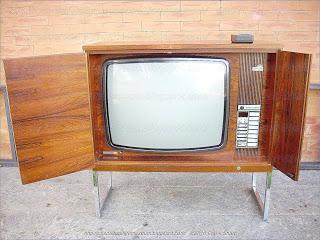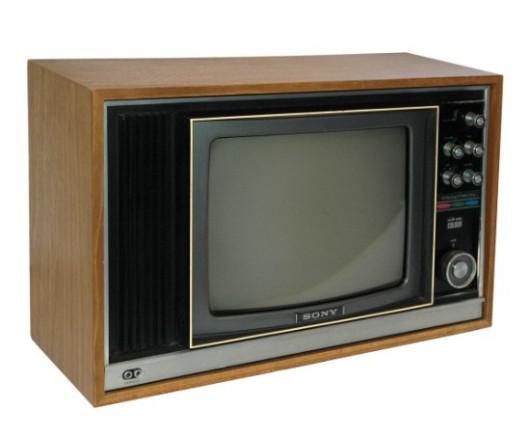The first image is the image on the left, the second image is the image on the right. Examine the images to the left and right. Is the description "An image shows an old-fashioned wood-cased TV set elevated off the ground on some type of legs." accurate? Answer yes or no. Yes. The first image is the image on the left, the second image is the image on the right. For the images displayed, is the sentence "One of the televisions is not the console type." factually correct? Answer yes or no. No. 